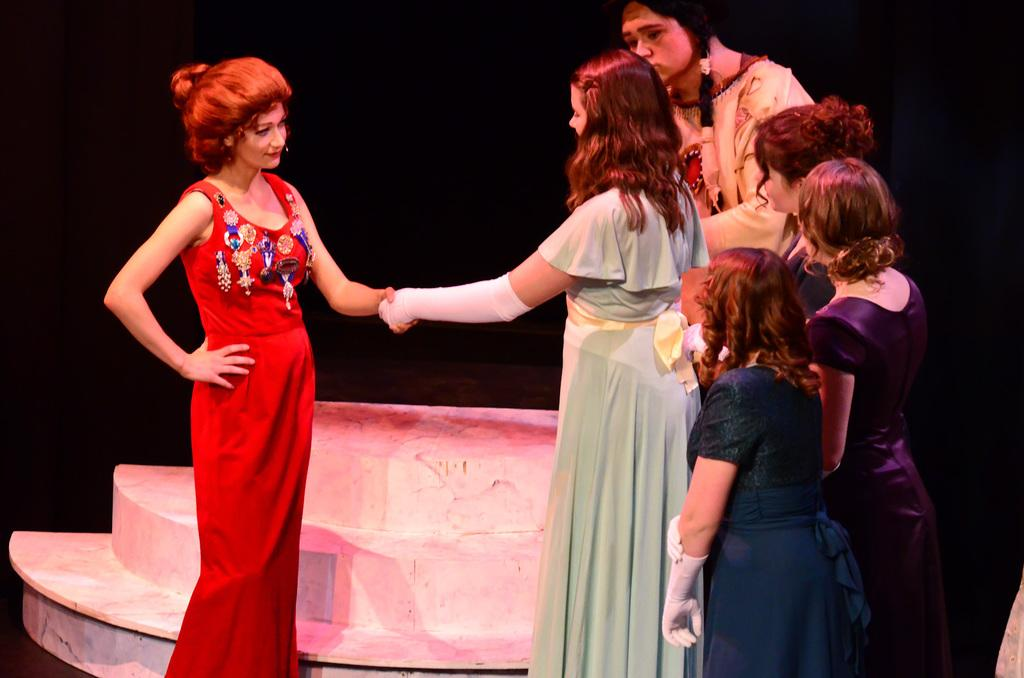How many people are in the image? There are people in the image, but the exact number is not specified. What are some of the people doing in the image? Some of the people are standing, and two people are shaking hands. What can be seen in the background of the image? There is a staircase in the background of the image. What type of riddle is being solved by the people in the image? There is no indication in the image that the people are solving a riddle. What is the texture of the chin of the person in the front of the image? There is no person in the front of the image mentioned in the facts, and therefore we cannot determine the texture of their chin. 